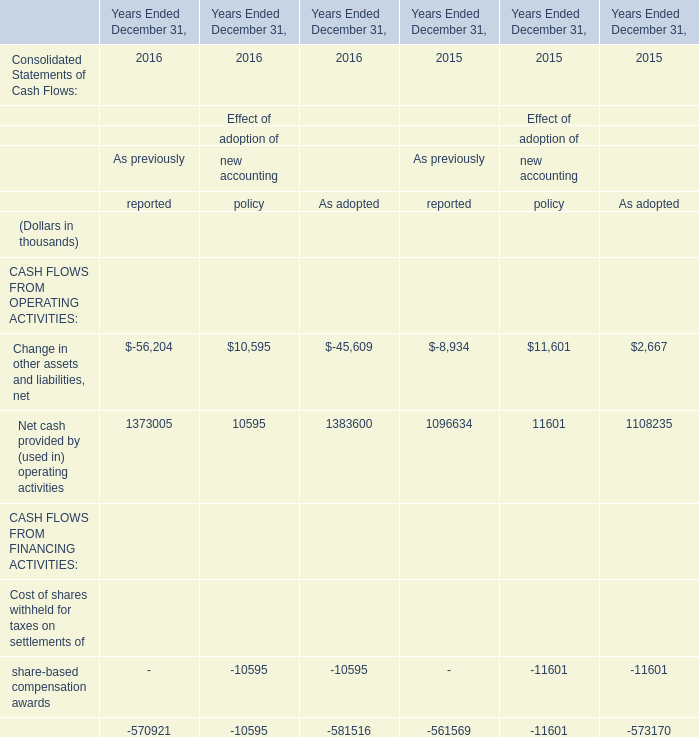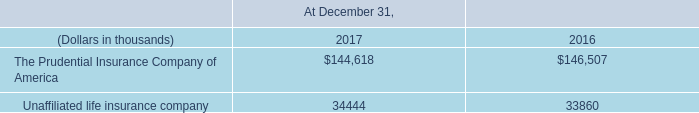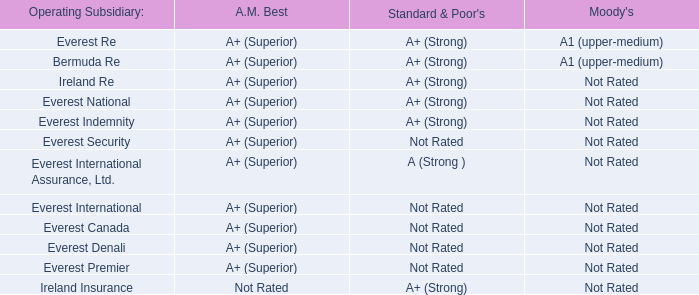at december 31 , 2017 under the 2010 employee plan what was the percent of shares that had been granted 
Computations: (4000000 - 2553473)
Answer: 1446527.0. 